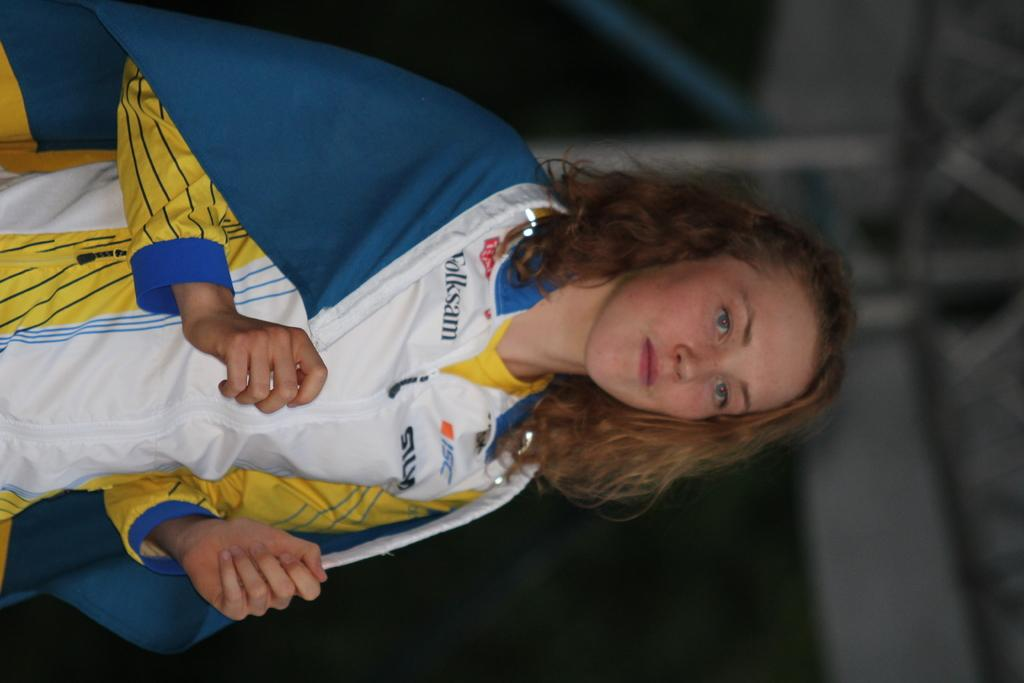<image>
Provide a brief description of the given image. A gilr wearing a white top with Folksam and ISC written on it drapes a blue flag over her shoulders. 